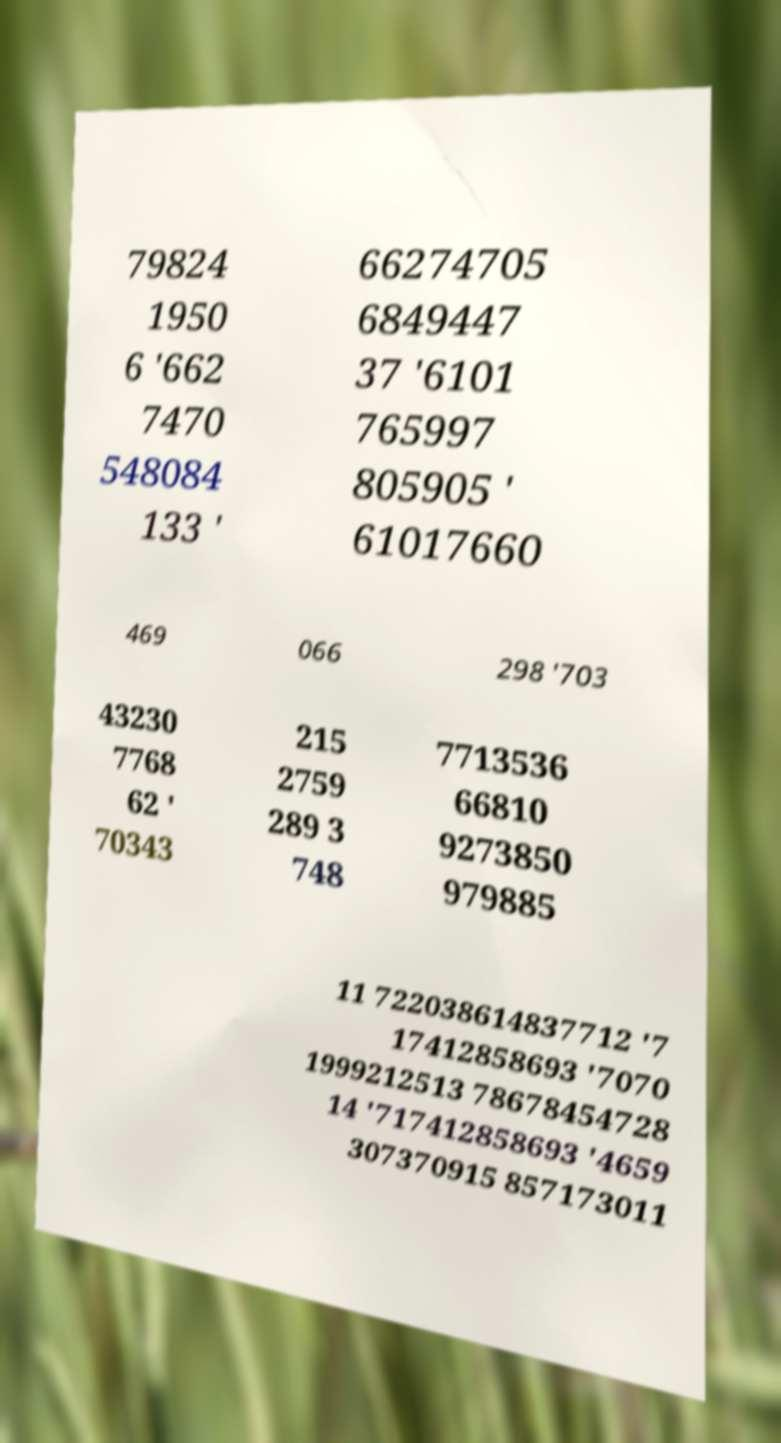Please read and relay the text visible in this image. What does it say? 79824 1950 6 '662 7470 548084 133 ' 66274705 6849447 37 '6101 765997 805905 ' 61017660 469 066 298 '703 43230 7768 62 ' 70343 215 2759 289 3 748 7713536 66810 9273850 979885 11 722038614837712 '7 17412858693 '7070 1999212513 78678454728 14 '717412858693 '4659 307370915 857173011 